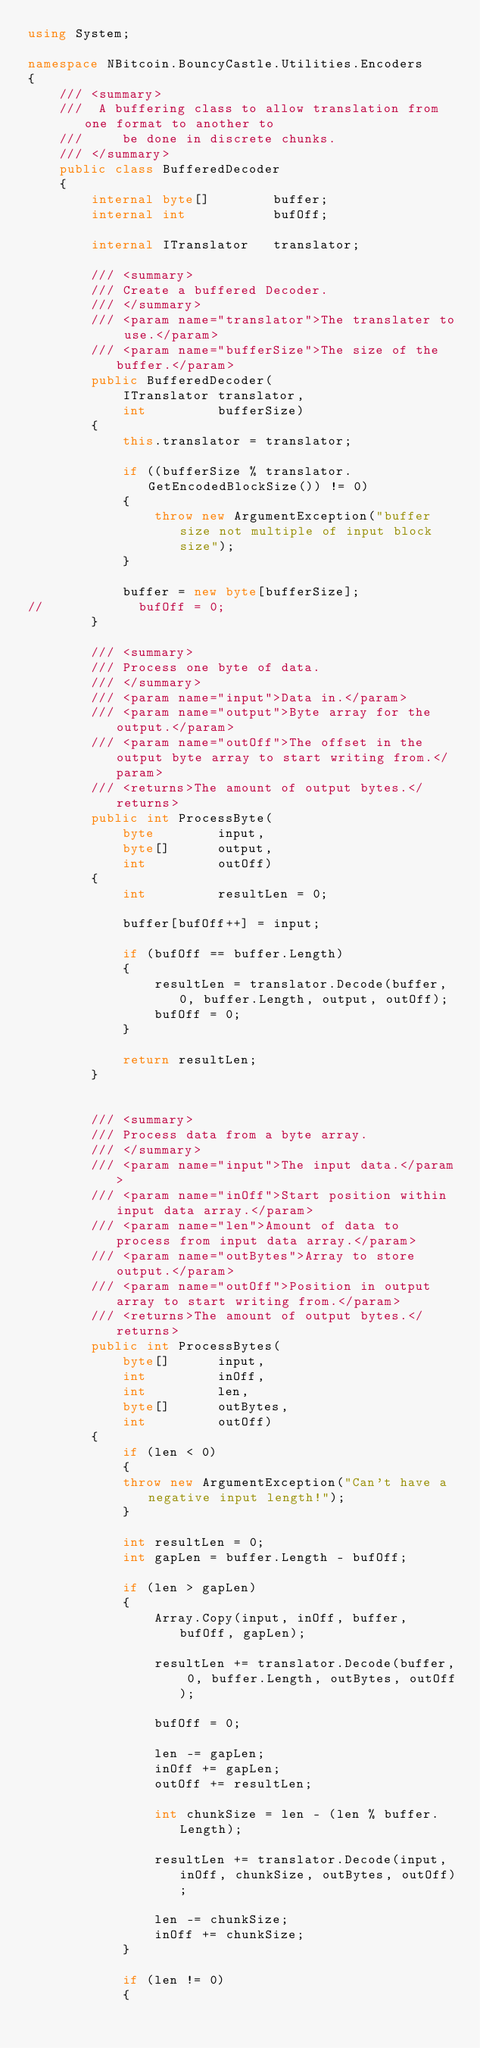Convert code to text. <code><loc_0><loc_0><loc_500><loc_500><_C#_>using System;

namespace NBitcoin.BouncyCastle.Utilities.Encoders
{
    /// <summary>
    ///  A buffering class to allow translation from one format to another to
    ///     be done in discrete chunks.
    /// </summary>
    public class BufferedDecoder
    {
        internal byte[]        buffer;
        internal int           bufOff;

        internal ITranslator   translator;

        /// <summary>
        /// Create a buffered Decoder.
        /// </summary>
        /// <param name="translator">The translater to use.</param>
        /// <param name="bufferSize">The size of the buffer.</param>
        public BufferedDecoder(
            ITranslator translator,
            int         bufferSize)
        {
            this.translator = translator;

            if ((bufferSize % translator.GetEncodedBlockSize()) != 0)
            {
                throw new ArgumentException("buffer size not multiple of input block size");
            }

            buffer = new byte[bufferSize];
//            bufOff = 0;
        }

        /// <summary>
        /// Process one byte of data.
        /// </summary>
        /// <param name="input">Data in.</param>
        /// <param name="output">Byte array for the output.</param>
        /// <param name="outOff">The offset in the output byte array to start writing from.</param>
        /// <returns>The amount of output bytes.</returns>
        public int ProcessByte(
            byte        input,
            byte[]      output,
            int         outOff)
        {
            int         resultLen = 0;

            buffer[bufOff++] = input;

            if (bufOff == buffer.Length)
            {
                resultLen = translator.Decode(buffer, 0, buffer.Length, output, outOff);
                bufOff = 0;
            }

            return resultLen;
        }


        /// <summary>
        /// Process data from a byte array.
        /// </summary>
        /// <param name="input">The input data.</param>
        /// <param name="inOff">Start position within input data array.</param>
        /// <param name="len">Amount of data to process from input data array.</param>
        /// <param name="outBytes">Array to store output.</param>
        /// <param name="outOff">Position in output array to start writing from.</param>
        /// <returns>The amount of output bytes.</returns>
        public int ProcessBytes(
            byte[]      input,
            int         inOff,
            int         len,
            byte[]      outBytes,
            int         outOff)
        {
            if (len < 0)
            {
            throw new ArgumentException("Can't have a negative input length!");
            }

            int resultLen = 0;
            int gapLen = buffer.Length - bufOff;

            if (len > gapLen)
            {
                Array.Copy(input, inOff, buffer, bufOff, gapLen);

                resultLen += translator.Decode(buffer, 0, buffer.Length, outBytes, outOff);

                bufOff = 0;

                len -= gapLen;
                inOff += gapLen;
                outOff += resultLen;

                int chunkSize = len - (len % buffer.Length);

                resultLen += translator.Decode(input, inOff, chunkSize, outBytes, outOff);

                len -= chunkSize;
                inOff += chunkSize;
            }

            if (len != 0)
            {</code> 